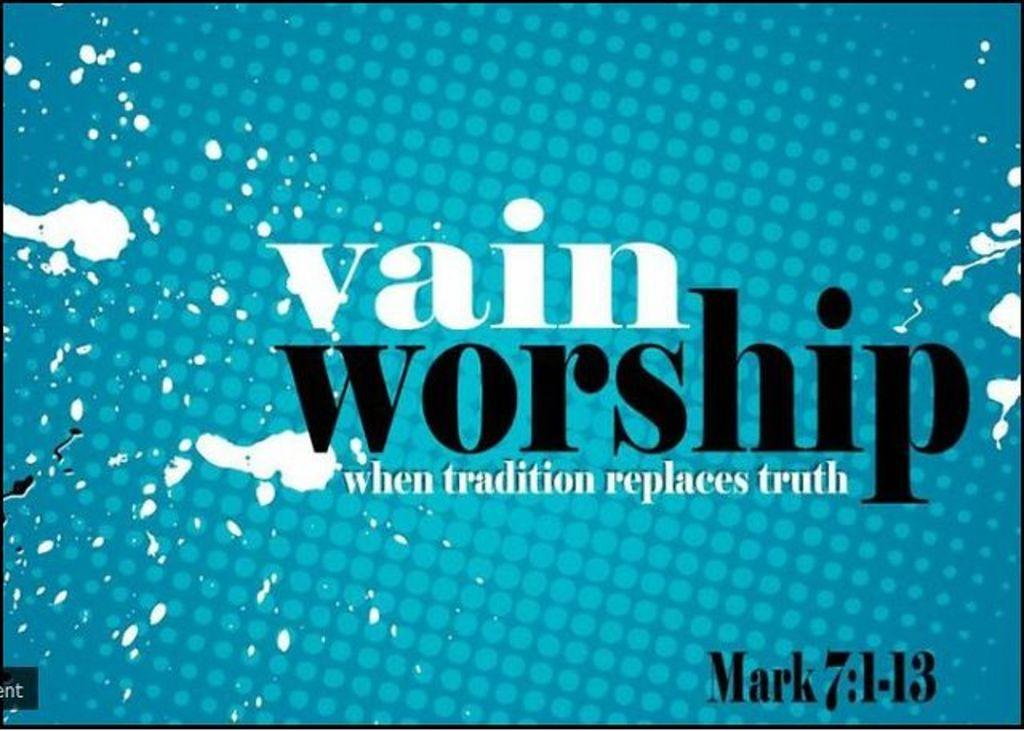<image>
Provide a brief description of the given image. Blue background with black and white words that say "Vain worship". 